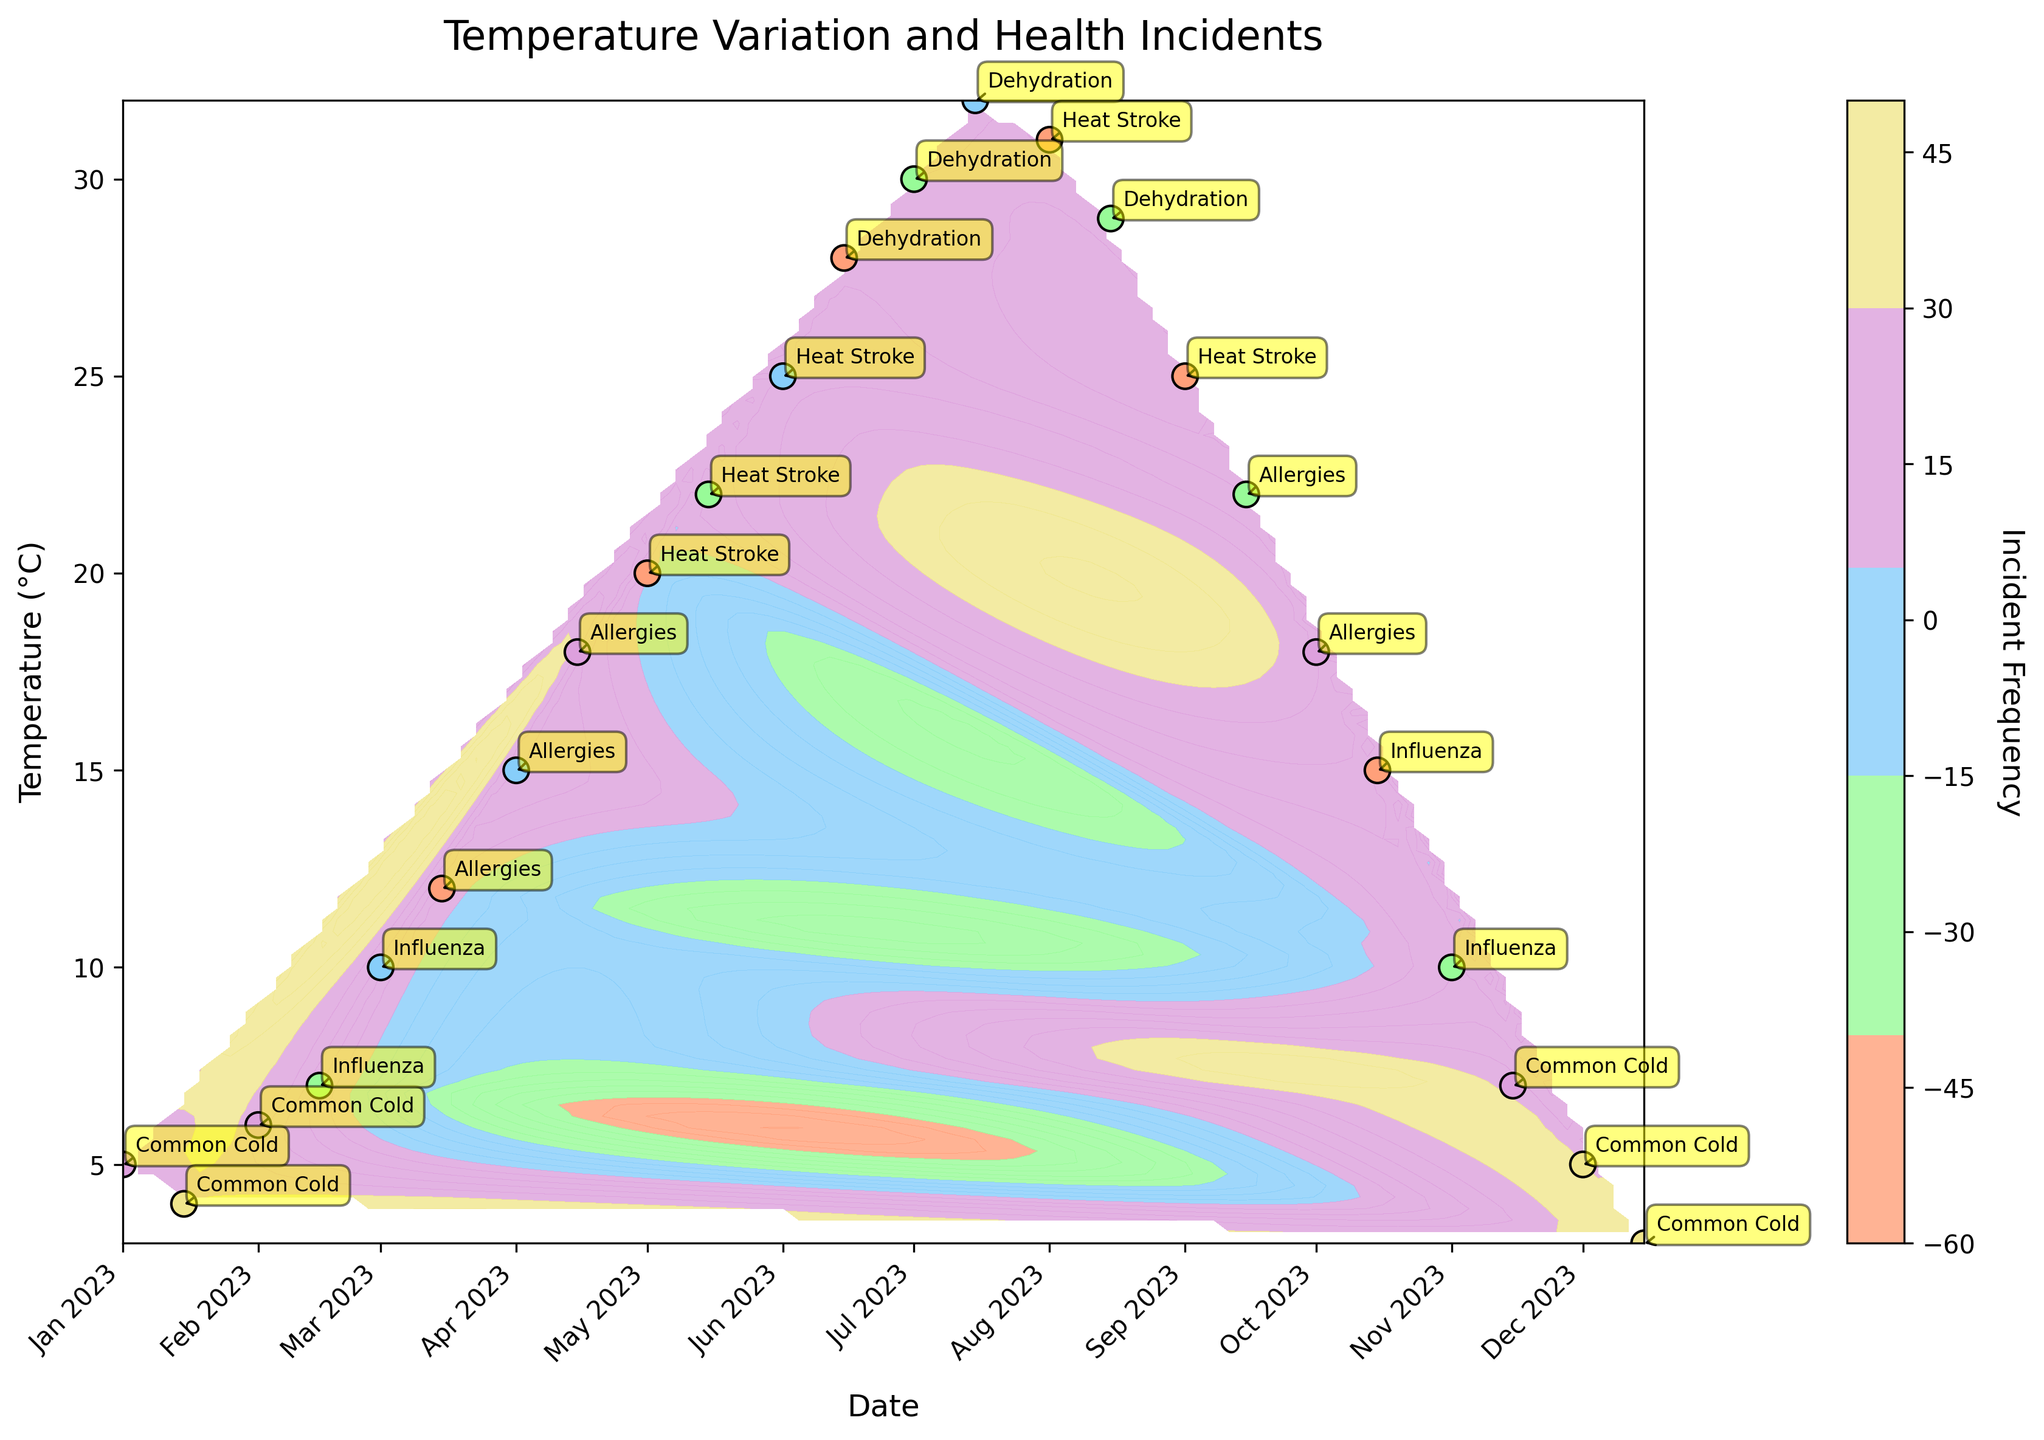What's the title of the plot? The title of the plot is mentioned at the top of the figure. You can read the text directly.
Answer: Temperature Variation and Health Incidents What does the color bar represent? The color bar is labeled on the right side of the figure. It typically indicates the value range it represents, in this case, it shows 'Incident Frequency'.
Answer: Incident Frequency Which month has the highest frequency of Health Incidents? Look at the highest values on the Incident Frequency color bar and find the corresponding points on the plot. The highest frequency incidents appear around December.
Answer: December What health incidents are associated with high temperatures in July? Look at the points plotted in July and their labels. The points are associated with "Dehydration".
Answer: Dehydration Around what temperature range do Allergies incidents occur predominantly? Identify the points labeled "Allergies" on the plot and note their temperatures. These tend to be around 15 to 22 °C.
Answer: 15 to 22 °C How does the frequency of Common Cold incidents in January compare to December? Notice the numbers and color intensities at the points for January and December. January shows frequencies around 25-30, while December shows frequencies around 30-35.
Answer: December has higher frequencies Which incident has the lowest recorded frequency, and during which month does it occur? Check the scatter points with the least color intensity and validate the labels. The lowest is "Heat Stroke" in September with a frequency of 5.
Answer: Heat Stroke, September How many distinct health incidents are visible in the plot? Count all unique labels annotated on the plot. There are "Common Cold", "Influenza", "Allergies", "Heat Stroke", and "Dehydration."
Answer: 5 Compare the incident frequencies of Heat Stroke in May and June. Which one has a higher frequency? Identify the Heat Stroke labels in May and June and compare the frequencies. May has 5 and 12, while June has 18. June has higher frequencies.
Answer: June 